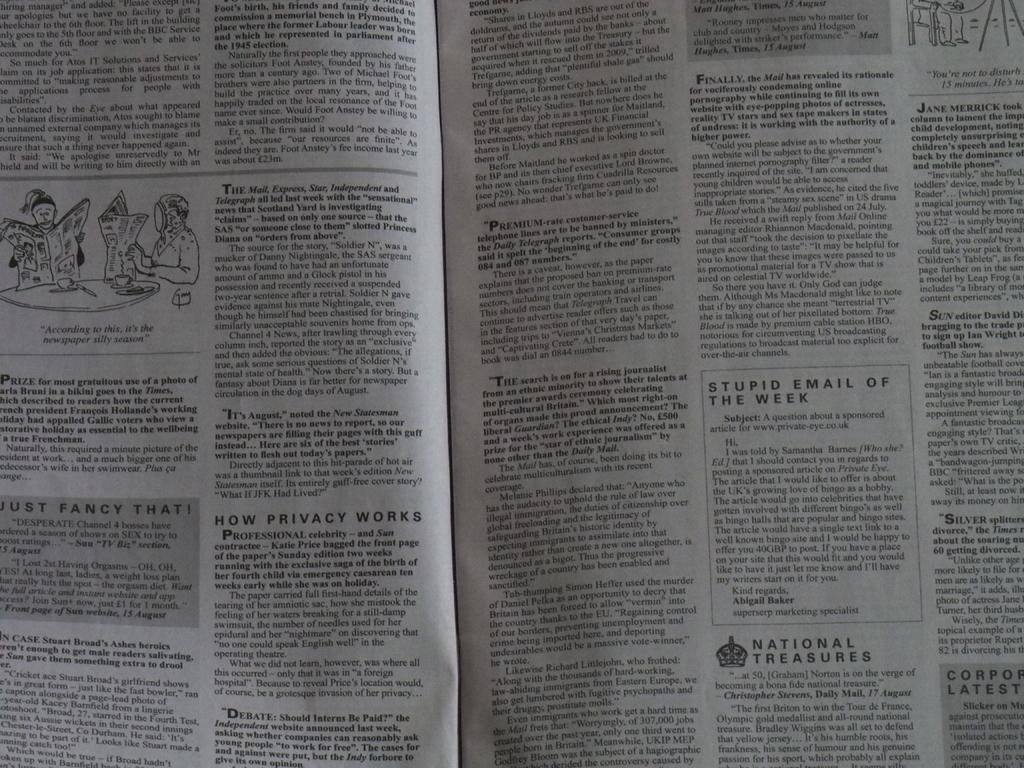<image>
Offer a succinct explanation of the picture presented. Newspaper with Stupid E-mail of the Week section. 